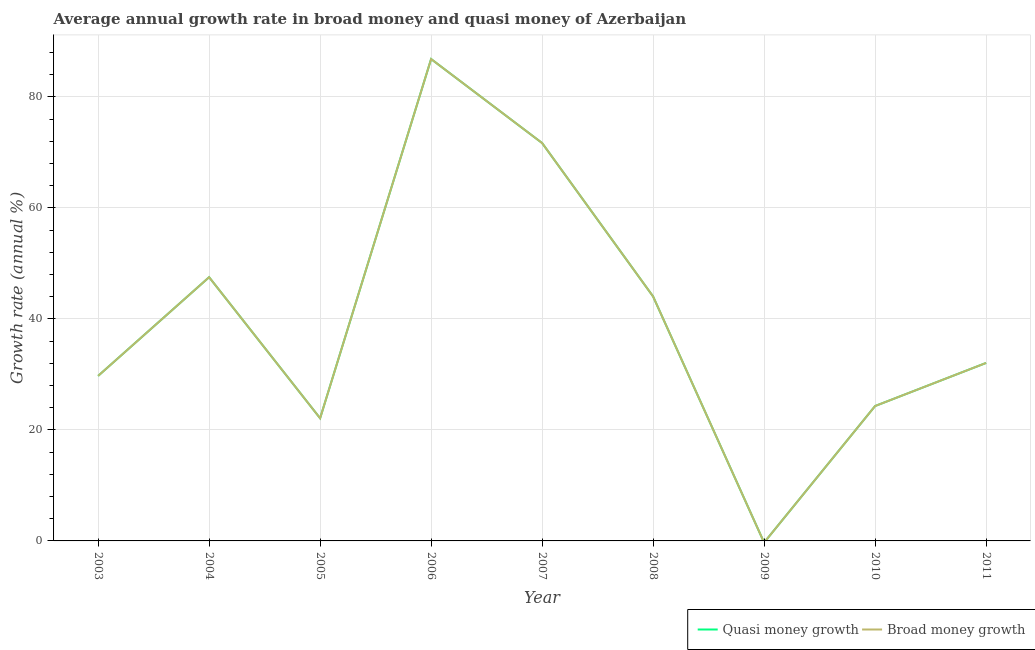Is the number of lines equal to the number of legend labels?
Offer a terse response. No. What is the annual growth rate in quasi money in 2006?
Your response must be concise. 86.81. Across all years, what is the maximum annual growth rate in broad money?
Provide a short and direct response. 86.81. In which year was the annual growth rate in quasi money maximum?
Make the answer very short. 2006. What is the total annual growth rate in broad money in the graph?
Make the answer very short. 358.25. What is the difference between the annual growth rate in quasi money in 2003 and that in 2008?
Your answer should be very brief. -14.31. What is the difference between the annual growth rate in broad money in 2005 and the annual growth rate in quasi money in 2009?
Offer a terse response. 22.1. What is the average annual growth rate in broad money per year?
Your answer should be compact. 39.81. In the year 2006, what is the difference between the annual growth rate in quasi money and annual growth rate in broad money?
Offer a terse response. 0. What is the ratio of the annual growth rate in broad money in 2003 to that in 2006?
Provide a short and direct response. 0.34. Is the annual growth rate in quasi money in 2004 less than that in 2010?
Provide a succinct answer. No. What is the difference between the highest and the second highest annual growth rate in quasi money?
Provide a succinct answer. 15.13. What is the difference between the highest and the lowest annual growth rate in quasi money?
Give a very brief answer. 86.81. In how many years, is the annual growth rate in quasi money greater than the average annual growth rate in quasi money taken over all years?
Offer a very short reply. 4. How many lines are there?
Offer a terse response. 2. How many years are there in the graph?
Your response must be concise. 9. What is the difference between two consecutive major ticks on the Y-axis?
Provide a succinct answer. 20. Does the graph contain any zero values?
Your answer should be very brief. Yes. How many legend labels are there?
Keep it short and to the point. 2. What is the title of the graph?
Provide a succinct answer. Average annual growth rate in broad money and quasi money of Azerbaijan. What is the label or title of the Y-axis?
Your answer should be compact. Growth rate (annual %). What is the Growth rate (annual %) in Quasi money growth in 2003?
Offer a terse response. 29.73. What is the Growth rate (annual %) of Broad money growth in 2003?
Offer a terse response. 29.73. What is the Growth rate (annual %) of Quasi money growth in 2004?
Offer a very short reply. 47.51. What is the Growth rate (annual %) in Broad money growth in 2004?
Give a very brief answer. 47.51. What is the Growth rate (annual %) of Quasi money growth in 2005?
Ensure brevity in your answer.  22.1. What is the Growth rate (annual %) in Broad money growth in 2005?
Keep it short and to the point. 22.1. What is the Growth rate (annual %) of Quasi money growth in 2006?
Give a very brief answer. 86.81. What is the Growth rate (annual %) in Broad money growth in 2006?
Your response must be concise. 86.81. What is the Growth rate (annual %) of Quasi money growth in 2007?
Offer a terse response. 71.68. What is the Growth rate (annual %) in Broad money growth in 2007?
Your response must be concise. 71.68. What is the Growth rate (annual %) in Quasi money growth in 2008?
Keep it short and to the point. 44.04. What is the Growth rate (annual %) of Broad money growth in 2008?
Make the answer very short. 44.04. What is the Growth rate (annual %) in Broad money growth in 2009?
Offer a very short reply. 0. What is the Growth rate (annual %) of Quasi money growth in 2010?
Give a very brief answer. 24.3. What is the Growth rate (annual %) of Broad money growth in 2010?
Provide a succinct answer. 24.3. What is the Growth rate (annual %) in Quasi money growth in 2011?
Give a very brief answer. 32.07. What is the Growth rate (annual %) in Broad money growth in 2011?
Your response must be concise. 32.07. Across all years, what is the maximum Growth rate (annual %) of Quasi money growth?
Ensure brevity in your answer.  86.81. Across all years, what is the maximum Growth rate (annual %) of Broad money growth?
Make the answer very short. 86.81. Across all years, what is the minimum Growth rate (annual %) in Quasi money growth?
Provide a short and direct response. 0. Across all years, what is the minimum Growth rate (annual %) in Broad money growth?
Offer a terse response. 0. What is the total Growth rate (annual %) of Quasi money growth in the graph?
Provide a succinct answer. 358.25. What is the total Growth rate (annual %) of Broad money growth in the graph?
Your response must be concise. 358.25. What is the difference between the Growth rate (annual %) of Quasi money growth in 2003 and that in 2004?
Provide a short and direct response. -17.78. What is the difference between the Growth rate (annual %) in Broad money growth in 2003 and that in 2004?
Offer a very short reply. -17.78. What is the difference between the Growth rate (annual %) of Quasi money growth in 2003 and that in 2005?
Ensure brevity in your answer.  7.63. What is the difference between the Growth rate (annual %) in Broad money growth in 2003 and that in 2005?
Your answer should be compact. 7.63. What is the difference between the Growth rate (annual %) in Quasi money growth in 2003 and that in 2006?
Your answer should be very brief. -57.08. What is the difference between the Growth rate (annual %) of Broad money growth in 2003 and that in 2006?
Offer a terse response. -57.08. What is the difference between the Growth rate (annual %) in Quasi money growth in 2003 and that in 2007?
Your response must be concise. -41.95. What is the difference between the Growth rate (annual %) in Broad money growth in 2003 and that in 2007?
Your answer should be compact. -41.95. What is the difference between the Growth rate (annual %) of Quasi money growth in 2003 and that in 2008?
Offer a very short reply. -14.31. What is the difference between the Growth rate (annual %) in Broad money growth in 2003 and that in 2008?
Make the answer very short. -14.31. What is the difference between the Growth rate (annual %) in Quasi money growth in 2003 and that in 2010?
Your answer should be very brief. 5.43. What is the difference between the Growth rate (annual %) of Broad money growth in 2003 and that in 2010?
Provide a short and direct response. 5.43. What is the difference between the Growth rate (annual %) in Quasi money growth in 2003 and that in 2011?
Ensure brevity in your answer.  -2.34. What is the difference between the Growth rate (annual %) in Broad money growth in 2003 and that in 2011?
Make the answer very short. -2.34. What is the difference between the Growth rate (annual %) in Quasi money growth in 2004 and that in 2005?
Provide a short and direct response. 25.41. What is the difference between the Growth rate (annual %) in Broad money growth in 2004 and that in 2005?
Ensure brevity in your answer.  25.41. What is the difference between the Growth rate (annual %) of Quasi money growth in 2004 and that in 2006?
Provide a succinct answer. -39.3. What is the difference between the Growth rate (annual %) of Broad money growth in 2004 and that in 2006?
Your answer should be very brief. -39.3. What is the difference between the Growth rate (annual %) of Quasi money growth in 2004 and that in 2007?
Provide a succinct answer. -24.17. What is the difference between the Growth rate (annual %) of Broad money growth in 2004 and that in 2007?
Provide a succinct answer. -24.17. What is the difference between the Growth rate (annual %) of Quasi money growth in 2004 and that in 2008?
Ensure brevity in your answer.  3.47. What is the difference between the Growth rate (annual %) in Broad money growth in 2004 and that in 2008?
Give a very brief answer. 3.47. What is the difference between the Growth rate (annual %) in Quasi money growth in 2004 and that in 2010?
Keep it short and to the point. 23.21. What is the difference between the Growth rate (annual %) in Broad money growth in 2004 and that in 2010?
Your response must be concise. 23.21. What is the difference between the Growth rate (annual %) in Quasi money growth in 2004 and that in 2011?
Your response must be concise. 15.45. What is the difference between the Growth rate (annual %) in Broad money growth in 2004 and that in 2011?
Give a very brief answer. 15.45. What is the difference between the Growth rate (annual %) in Quasi money growth in 2005 and that in 2006?
Provide a short and direct response. -64.71. What is the difference between the Growth rate (annual %) in Broad money growth in 2005 and that in 2006?
Your answer should be very brief. -64.71. What is the difference between the Growth rate (annual %) of Quasi money growth in 2005 and that in 2007?
Your answer should be compact. -49.58. What is the difference between the Growth rate (annual %) of Broad money growth in 2005 and that in 2007?
Provide a short and direct response. -49.58. What is the difference between the Growth rate (annual %) in Quasi money growth in 2005 and that in 2008?
Your answer should be very brief. -21.93. What is the difference between the Growth rate (annual %) in Broad money growth in 2005 and that in 2008?
Provide a succinct answer. -21.93. What is the difference between the Growth rate (annual %) of Quasi money growth in 2005 and that in 2010?
Your answer should be very brief. -2.2. What is the difference between the Growth rate (annual %) of Broad money growth in 2005 and that in 2010?
Ensure brevity in your answer.  -2.2. What is the difference between the Growth rate (annual %) in Quasi money growth in 2005 and that in 2011?
Give a very brief answer. -9.96. What is the difference between the Growth rate (annual %) of Broad money growth in 2005 and that in 2011?
Give a very brief answer. -9.96. What is the difference between the Growth rate (annual %) in Quasi money growth in 2006 and that in 2007?
Your answer should be very brief. 15.13. What is the difference between the Growth rate (annual %) of Broad money growth in 2006 and that in 2007?
Your answer should be very brief. 15.13. What is the difference between the Growth rate (annual %) of Quasi money growth in 2006 and that in 2008?
Give a very brief answer. 42.78. What is the difference between the Growth rate (annual %) of Broad money growth in 2006 and that in 2008?
Keep it short and to the point. 42.78. What is the difference between the Growth rate (annual %) in Quasi money growth in 2006 and that in 2010?
Offer a terse response. 62.51. What is the difference between the Growth rate (annual %) in Broad money growth in 2006 and that in 2010?
Ensure brevity in your answer.  62.51. What is the difference between the Growth rate (annual %) of Quasi money growth in 2006 and that in 2011?
Provide a short and direct response. 54.75. What is the difference between the Growth rate (annual %) in Broad money growth in 2006 and that in 2011?
Provide a short and direct response. 54.75. What is the difference between the Growth rate (annual %) in Quasi money growth in 2007 and that in 2008?
Your answer should be very brief. 27.65. What is the difference between the Growth rate (annual %) of Broad money growth in 2007 and that in 2008?
Offer a terse response. 27.65. What is the difference between the Growth rate (annual %) of Quasi money growth in 2007 and that in 2010?
Your answer should be compact. 47.38. What is the difference between the Growth rate (annual %) of Broad money growth in 2007 and that in 2010?
Make the answer very short. 47.38. What is the difference between the Growth rate (annual %) in Quasi money growth in 2007 and that in 2011?
Offer a terse response. 39.62. What is the difference between the Growth rate (annual %) in Broad money growth in 2007 and that in 2011?
Make the answer very short. 39.62. What is the difference between the Growth rate (annual %) in Quasi money growth in 2008 and that in 2010?
Make the answer very short. 19.73. What is the difference between the Growth rate (annual %) of Broad money growth in 2008 and that in 2010?
Ensure brevity in your answer.  19.73. What is the difference between the Growth rate (annual %) of Quasi money growth in 2008 and that in 2011?
Your answer should be compact. 11.97. What is the difference between the Growth rate (annual %) in Broad money growth in 2008 and that in 2011?
Give a very brief answer. 11.97. What is the difference between the Growth rate (annual %) in Quasi money growth in 2010 and that in 2011?
Ensure brevity in your answer.  -7.76. What is the difference between the Growth rate (annual %) in Broad money growth in 2010 and that in 2011?
Your answer should be very brief. -7.76. What is the difference between the Growth rate (annual %) in Quasi money growth in 2003 and the Growth rate (annual %) in Broad money growth in 2004?
Provide a short and direct response. -17.78. What is the difference between the Growth rate (annual %) of Quasi money growth in 2003 and the Growth rate (annual %) of Broad money growth in 2005?
Provide a succinct answer. 7.63. What is the difference between the Growth rate (annual %) in Quasi money growth in 2003 and the Growth rate (annual %) in Broad money growth in 2006?
Ensure brevity in your answer.  -57.08. What is the difference between the Growth rate (annual %) of Quasi money growth in 2003 and the Growth rate (annual %) of Broad money growth in 2007?
Provide a short and direct response. -41.95. What is the difference between the Growth rate (annual %) in Quasi money growth in 2003 and the Growth rate (annual %) in Broad money growth in 2008?
Make the answer very short. -14.31. What is the difference between the Growth rate (annual %) in Quasi money growth in 2003 and the Growth rate (annual %) in Broad money growth in 2010?
Your response must be concise. 5.43. What is the difference between the Growth rate (annual %) in Quasi money growth in 2003 and the Growth rate (annual %) in Broad money growth in 2011?
Provide a succinct answer. -2.34. What is the difference between the Growth rate (annual %) of Quasi money growth in 2004 and the Growth rate (annual %) of Broad money growth in 2005?
Offer a very short reply. 25.41. What is the difference between the Growth rate (annual %) of Quasi money growth in 2004 and the Growth rate (annual %) of Broad money growth in 2006?
Make the answer very short. -39.3. What is the difference between the Growth rate (annual %) in Quasi money growth in 2004 and the Growth rate (annual %) in Broad money growth in 2007?
Give a very brief answer. -24.17. What is the difference between the Growth rate (annual %) in Quasi money growth in 2004 and the Growth rate (annual %) in Broad money growth in 2008?
Offer a very short reply. 3.47. What is the difference between the Growth rate (annual %) in Quasi money growth in 2004 and the Growth rate (annual %) in Broad money growth in 2010?
Your answer should be compact. 23.21. What is the difference between the Growth rate (annual %) in Quasi money growth in 2004 and the Growth rate (annual %) in Broad money growth in 2011?
Give a very brief answer. 15.45. What is the difference between the Growth rate (annual %) in Quasi money growth in 2005 and the Growth rate (annual %) in Broad money growth in 2006?
Give a very brief answer. -64.71. What is the difference between the Growth rate (annual %) of Quasi money growth in 2005 and the Growth rate (annual %) of Broad money growth in 2007?
Offer a terse response. -49.58. What is the difference between the Growth rate (annual %) of Quasi money growth in 2005 and the Growth rate (annual %) of Broad money growth in 2008?
Provide a short and direct response. -21.93. What is the difference between the Growth rate (annual %) in Quasi money growth in 2005 and the Growth rate (annual %) in Broad money growth in 2010?
Provide a short and direct response. -2.2. What is the difference between the Growth rate (annual %) of Quasi money growth in 2005 and the Growth rate (annual %) of Broad money growth in 2011?
Make the answer very short. -9.96. What is the difference between the Growth rate (annual %) of Quasi money growth in 2006 and the Growth rate (annual %) of Broad money growth in 2007?
Make the answer very short. 15.13. What is the difference between the Growth rate (annual %) of Quasi money growth in 2006 and the Growth rate (annual %) of Broad money growth in 2008?
Your answer should be very brief. 42.78. What is the difference between the Growth rate (annual %) in Quasi money growth in 2006 and the Growth rate (annual %) in Broad money growth in 2010?
Give a very brief answer. 62.51. What is the difference between the Growth rate (annual %) of Quasi money growth in 2006 and the Growth rate (annual %) of Broad money growth in 2011?
Provide a short and direct response. 54.75. What is the difference between the Growth rate (annual %) in Quasi money growth in 2007 and the Growth rate (annual %) in Broad money growth in 2008?
Your response must be concise. 27.65. What is the difference between the Growth rate (annual %) in Quasi money growth in 2007 and the Growth rate (annual %) in Broad money growth in 2010?
Offer a very short reply. 47.38. What is the difference between the Growth rate (annual %) of Quasi money growth in 2007 and the Growth rate (annual %) of Broad money growth in 2011?
Make the answer very short. 39.62. What is the difference between the Growth rate (annual %) of Quasi money growth in 2008 and the Growth rate (annual %) of Broad money growth in 2010?
Offer a terse response. 19.73. What is the difference between the Growth rate (annual %) of Quasi money growth in 2008 and the Growth rate (annual %) of Broad money growth in 2011?
Ensure brevity in your answer.  11.97. What is the difference between the Growth rate (annual %) of Quasi money growth in 2010 and the Growth rate (annual %) of Broad money growth in 2011?
Give a very brief answer. -7.76. What is the average Growth rate (annual %) in Quasi money growth per year?
Your answer should be compact. 39.81. What is the average Growth rate (annual %) in Broad money growth per year?
Provide a short and direct response. 39.81. In the year 2003, what is the difference between the Growth rate (annual %) in Quasi money growth and Growth rate (annual %) in Broad money growth?
Your answer should be compact. 0. In the year 2004, what is the difference between the Growth rate (annual %) in Quasi money growth and Growth rate (annual %) in Broad money growth?
Your answer should be very brief. 0. In the year 2005, what is the difference between the Growth rate (annual %) in Quasi money growth and Growth rate (annual %) in Broad money growth?
Offer a terse response. 0. In the year 2006, what is the difference between the Growth rate (annual %) of Quasi money growth and Growth rate (annual %) of Broad money growth?
Keep it short and to the point. 0. In the year 2007, what is the difference between the Growth rate (annual %) in Quasi money growth and Growth rate (annual %) in Broad money growth?
Provide a short and direct response. 0. In the year 2008, what is the difference between the Growth rate (annual %) in Quasi money growth and Growth rate (annual %) in Broad money growth?
Provide a succinct answer. 0. In the year 2010, what is the difference between the Growth rate (annual %) in Quasi money growth and Growth rate (annual %) in Broad money growth?
Your answer should be very brief. 0. In the year 2011, what is the difference between the Growth rate (annual %) of Quasi money growth and Growth rate (annual %) of Broad money growth?
Provide a succinct answer. 0. What is the ratio of the Growth rate (annual %) of Quasi money growth in 2003 to that in 2004?
Provide a short and direct response. 0.63. What is the ratio of the Growth rate (annual %) of Broad money growth in 2003 to that in 2004?
Offer a terse response. 0.63. What is the ratio of the Growth rate (annual %) of Quasi money growth in 2003 to that in 2005?
Provide a short and direct response. 1.35. What is the ratio of the Growth rate (annual %) of Broad money growth in 2003 to that in 2005?
Your response must be concise. 1.35. What is the ratio of the Growth rate (annual %) in Quasi money growth in 2003 to that in 2006?
Make the answer very short. 0.34. What is the ratio of the Growth rate (annual %) of Broad money growth in 2003 to that in 2006?
Provide a short and direct response. 0.34. What is the ratio of the Growth rate (annual %) in Quasi money growth in 2003 to that in 2007?
Your answer should be very brief. 0.41. What is the ratio of the Growth rate (annual %) of Broad money growth in 2003 to that in 2007?
Offer a very short reply. 0.41. What is the ratio of the Growth rate (annual %) in Quasi money growth in 2003 to that in 2008?
Make the answer very short. 0.68. What is the ratio of the Growth rate (annual %) of Broad money growth in 2003 to that in 2008?
Provide a short and direct response. 0.68. What is the ratio of the Growth rate (annual %) of Quasi money growth in 2003 to that in 2010?
Make the answer very short. 1.22. What is the ratio of the Growth rate (annual %) of Broad money growth in 2003 to that in 2010?
Your answer should be very brief. 1.22. What is the ratio of the Growth rate (annual %) in Quasi money growth in 2003 to that in 2011?
Keep it short and to the point. 0.93. What is the ratio of the Growth rate (annual %) in Broad money growth in 2003 to that in 2011?
Your answer should be very brief. 0.93. What is the ratio of the Growth rate (annual %) of Quasi money growth in 2004 to that in 2005?
Give a very brief answer. 2.15. What is the ratio of the Growth rate (annual %) of Broad money growth in 2004 to that in 2005?
Your answer should be very brief. 2.15. What is the ratio of the Growth rate (annual %) of Quasi money growth in 2004 to that in 2006?
Offer a terse response. 0.55. What is the ratio of the Growth rate (annual %) of Broad money growth in 2004 to that in 2006?
Offer a very short reply. 0.55. What is the ratio of the Growth rate (annual %) in Quasi money growth in 2004 to that in 2007?
Make the answer very short. 0.66. What is the ratio of the Growth rate (annual %) of Broad money growth in 2004 to that in 2007?
Your answer should be compact. 0.66. What is the ratio of the Growth rate (annual %) of Quasi money growth in 2004 to that in 2008?
Keep it short and to the point. 1.08. What is the ratio of the Growth rate (annual %) of Broad money growth in 2004 to that in 2008?
Offer a terse response. 1.08. What is the ratio of the Growth rate (annual %) of Quasi money growth in 2004 to that in 2010?
Your response must be concise. 1.95. What is the ratio of the Growth rate (annual %) in Broad money growth in 2004 to that in 2010?
Provide a short and direct response. 1.95. What is the ratio of the Growth rate (annual %) in Quasi money growth in 2004 to that in 2011?
Ensure brevity in your answer.  1.48. What is the ratio of the Growth rate (annual %) of Broad money growth in 2004 to that in 2011?
Give a very brief answer. 1.48. What is the ratio of the Growth rate (annual %) of Quasi money growth in 2005 to that in 2006?
Keep it short and to the point. 0.25. What is the ratio of the Growth rate (annual %) in Broad money growth in 2005 to that in 2006?
Make the answer very short. 0.25. What is the ratio of the Growth rate (annual %) in Quasi money growth in 2005 to that in 2007?
Provide a succinct answer. 0.31. What is the ratio of the Growth rate (annual %) of Broad money growth in 2005 to that in 2007?
Your answer should be very brief. 0.31. What is the ratio of the Growth rate (annual %) of Quasi money growth in 2005 to that in 2008?
Offer a very short reply. 0.5. What is the ratio of the Growth rate (annual %) of Broad money growth in 2005 to that in 2008?
Ensure brevity in your answer.  0.5. What is the ratio of the Growth rate (annual %) in Quasi money growth in 2005 to that in 2010?
Give a very brief answer. 0.91. What is the ratio of the Growth rate (annual %) of Broad money growth in 2005 to that in 2010?
Keep it short and to the point. 0.91. What is the ratio of the Growth rate (annual %) in Quasi money growth in 2005 to that in 2011?
Offer a terse response. 0.69. What is the ratio of the Growth rate (annual %) of Broad money growth in 2005 to that in 2011?
Make the answer very short. 0.69. What is the ratio of the Growth rate (annual %) in Quasi money growth in 2006 to that in 2007?
Make the answer very short. 1.21. What is the ratio of the Growth rate (annual %) of Broad money growth in 2006 to that in 2007?
Offer a very short reply. 1.21. What is the ratio of the Growth rate (annual %) in Quasi money growth in 2006 to that in 2008?
Your answer should be very brief. 1.97. What is the ratio of the Growth rate (annual %) in Broad money growth in 2006 to that in 2008?
Your answer should be very brief. 1.97. What is the ratio of the Growth rate (annual %) in Quasi money growth in 2006 to that in 2010?
Your response must be concise. 3.57. What is the ratio of the Growth rate (annual %) of Broad money growth in 2006 to that in 2010?
Your response must be concise. 3.57. What is the ratio of the Growth rate (annual %) in Quasi money growth in 2006 to that in 2011?
Keep it short and to the point. 2.71. What is the ratio of the Growth rate (annual %) in Broad money growth in 2006 to that in 2011?
Your answer should be compact. 2.71. What is the ratio of the Growth rate (annual %) of Quasi money growth in 2007 to that in 2008?
Offer a very short reply. 1.63. What is the ratio of the Growth rate (annual %) in Broad money growth in 2007 to that in 2008?
Provide a succinct answer. 1.63. What is the ratio of the Growth rate (annual %) of Quasi money growth in 2007 to that in 2010?
Your answer should be very brief. 2.95. What is the ratio of the Growth rate (annual %) of Broad money growth in 2007 to that in 2010?
Provide a succinct answer. 2.95. What is the ratio of the Growth rate (annual %) in Quasi money growth in 2007 to that in 2011?
Your answer should be compact. 2.24. What is the ratio of the Growth rate (annual %) of Broad money growth in 2007 to that in 2011?
Provide a succinct answer. 2.24. What is the ratio of the Growth rate (annual %) of Quasi money growth in 2008 to that in 2010?
Provide a succinct answer. 1.81. What is the ratio of the Growth rate (annual %) in Broad money growth in 2008 to that in 2010?
Ensure brevity in your answer.  1.81. What is the ratio of the Growth rate (annual %) of Quasi money growth in 2008 to that in 2011?
Ensure brevity in your answer.  1.37. What is the ratio of the Growth rate (annual %) in Broad money growth in 2008 to that in 2011?
Provide a succinct answer. 1.37. What is the ratio of the Growth rate (annual %) of Quasi money growth in 2010 to that in 2011?
Provide a short and direct response. 0.76. What is the ratio of the Growth rate (annual %) of Broad money growth in 2010 to that in 2011?
Your response must be concise. 0.76. What is the difference between the highest and the second highest Growth rate (annual %) of Quasi money growth?
Provide a short and direct response. 15.13. What is the difference between the highest and the second highest Growth rate (annual %) of Broad money growth?
Provide a succinct answer. 15.13. What is the difference between the highest and the lowest Growth rate (annual %) in Quasi money growth?
Your response must be concise. 86.81. What is the difference between the highest and the lowest Growth rate (annual %) in Broad money growth?
Your answer should be compact. 86.81. 